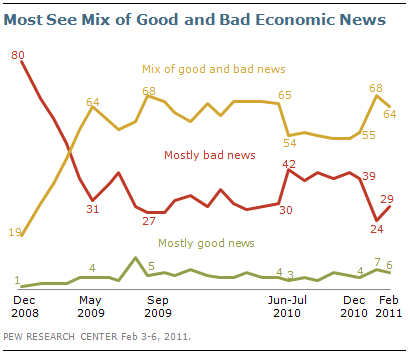How has the public's perception of economic news changed over time according to this graph? According to the graph, the public's perception of economic news has fluctuated over time. Initially, in December 2008, a significant portion of people saw the news as 'Mostly bad', which decreased until February 2009, and then began to rise again, peaking in May 2009. Conversely, the perception of 'Mostly good news' started very low but increased until a peak in September 2009. Overall, the sentiment of 'Mix of good and bad news' has generally stayed on top, showing that most people believed economic news contained a balance of positive and negative aspects. 